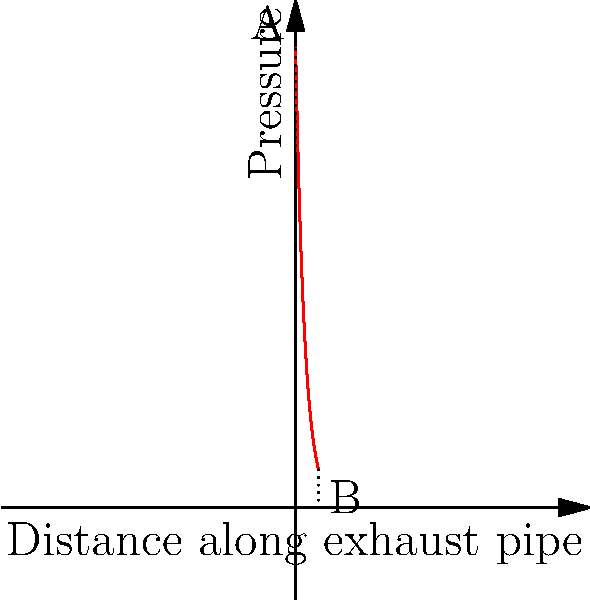In your modified sports car exhaust system, the pressure distribution along the pipe is modeled by the equation $P(x) = 100e^{-0.5x}$, where $P$ is the pressure in kPa and $x$ is the distance along the pipe in meters. What is the percentage decrease in pressure between point A (entrance) and point B (5 meters along the pipe)? To solve this problem, we'll follow these steps:

1) First, let's calculate the pressure at point A (x = 0 m):
   $P(0) = 100e^{-0.5(0)} = 100$ kPa

2) Now, let's calculate the pressure at point B (x = 5 m):
   $P(5) = 100e^{-0.5(5)} = 100e^{-2.5} \approx 8.21$ kPa

3) To find the percentage decrease, we use the formula:
   Percentage decrease = $\frac{\text{Decrease}}{\text{Original}} \times 100\%$

4) Decrease = $100 - 8.21 = 91.79$ kPa

5) Percentage decrease = $\frac{91.79}{100} \times 100\% = 91.79\%$

Therefore, the pressure decreases by approximately 91.79% over the 5-meter length of the exhaust pipe.
Answer: 91.79% 